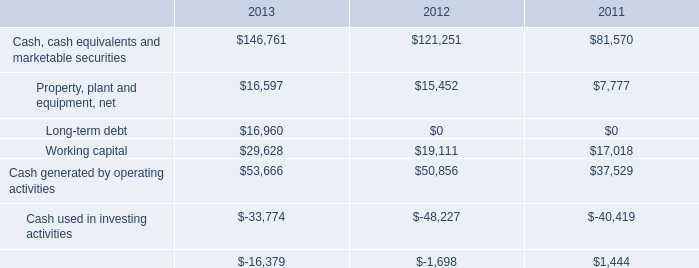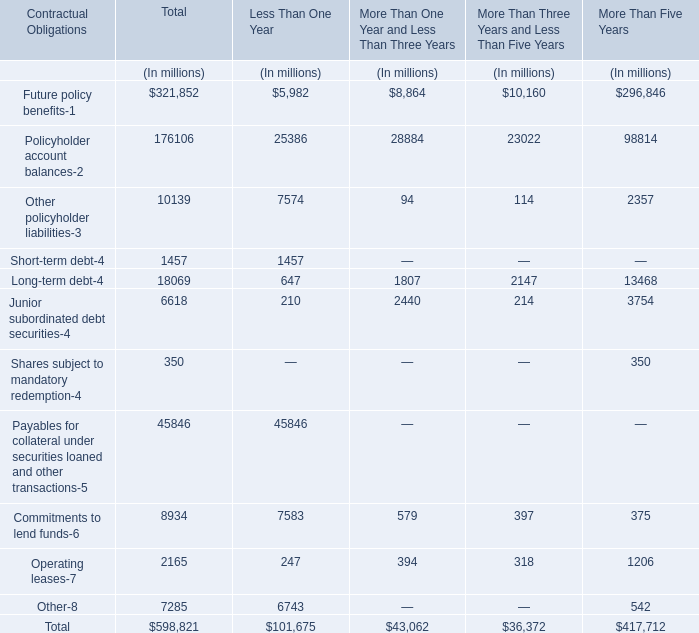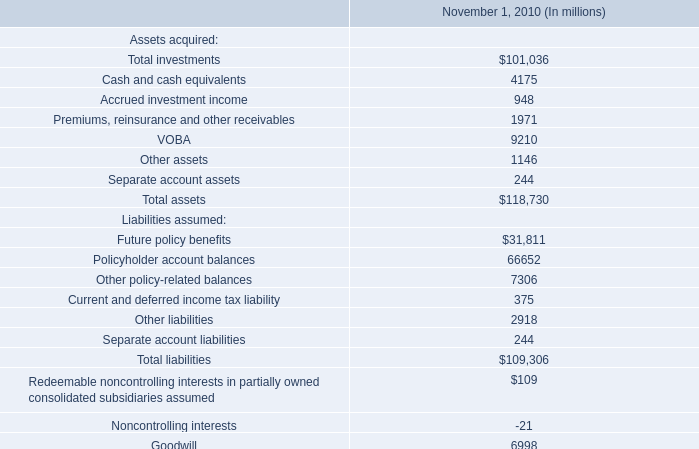What is the sum of the Junior subordinated debt securities-4 in the ections where Long-term debt-4 is positive? (in million) 
Computations: (6618 + 6618)
Answer: 13236.0. 